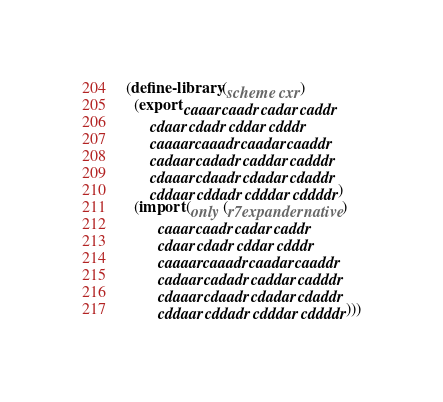<code> <loc_0><loc_0><loc_500><loc_500><_Scheme_>(define-library (scheme cxr)
  (export caaar caadr cadar caddr
	  cdaar cdadr cddar cdddr
	  caaaar caaadr caadar caaddr
	  cadaar cadadr caddar cadddr
	  cdaaar cdaadr cdadar cdaddr
	  cddaar cddadr cdddar cddddr)
  (import (only (r7expander native)
		caaar caadr cadar caddr
		cdaar cdadr cddar cdddr
		caaaar caaadr caadar caaddr
		cadaar cadadr caddar cadddr
		cdaaar cdaadr cdadar cdaddr
		cddaar cddadr cdddar cddddr)))
</code> 